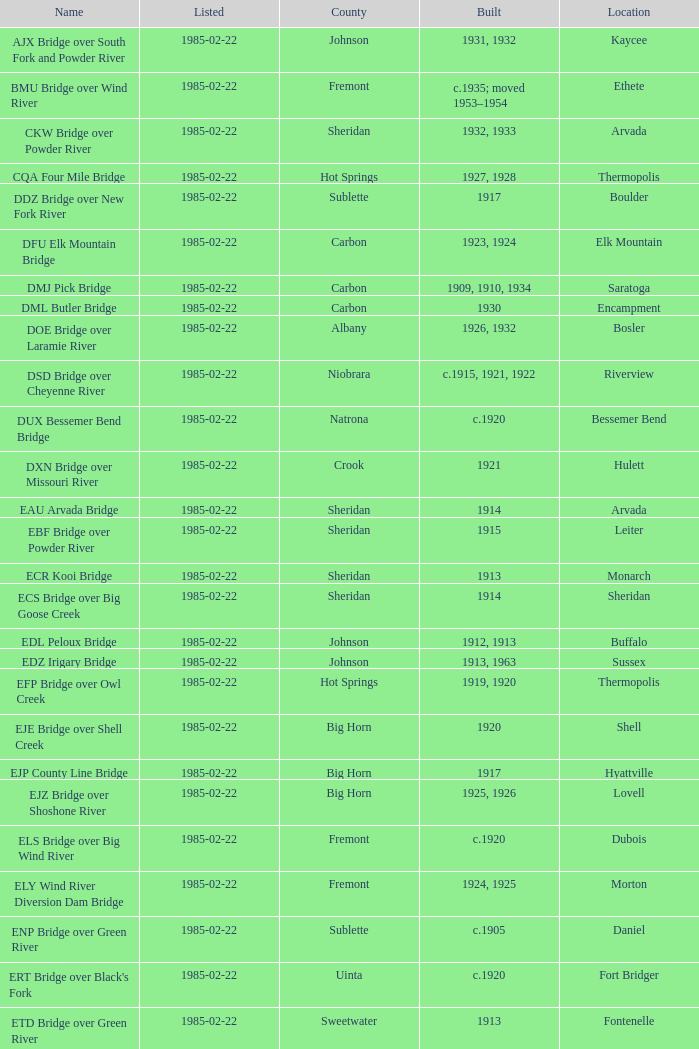What is the listed for the bridge at Daniel in Sublette county? 1985-02-22. 